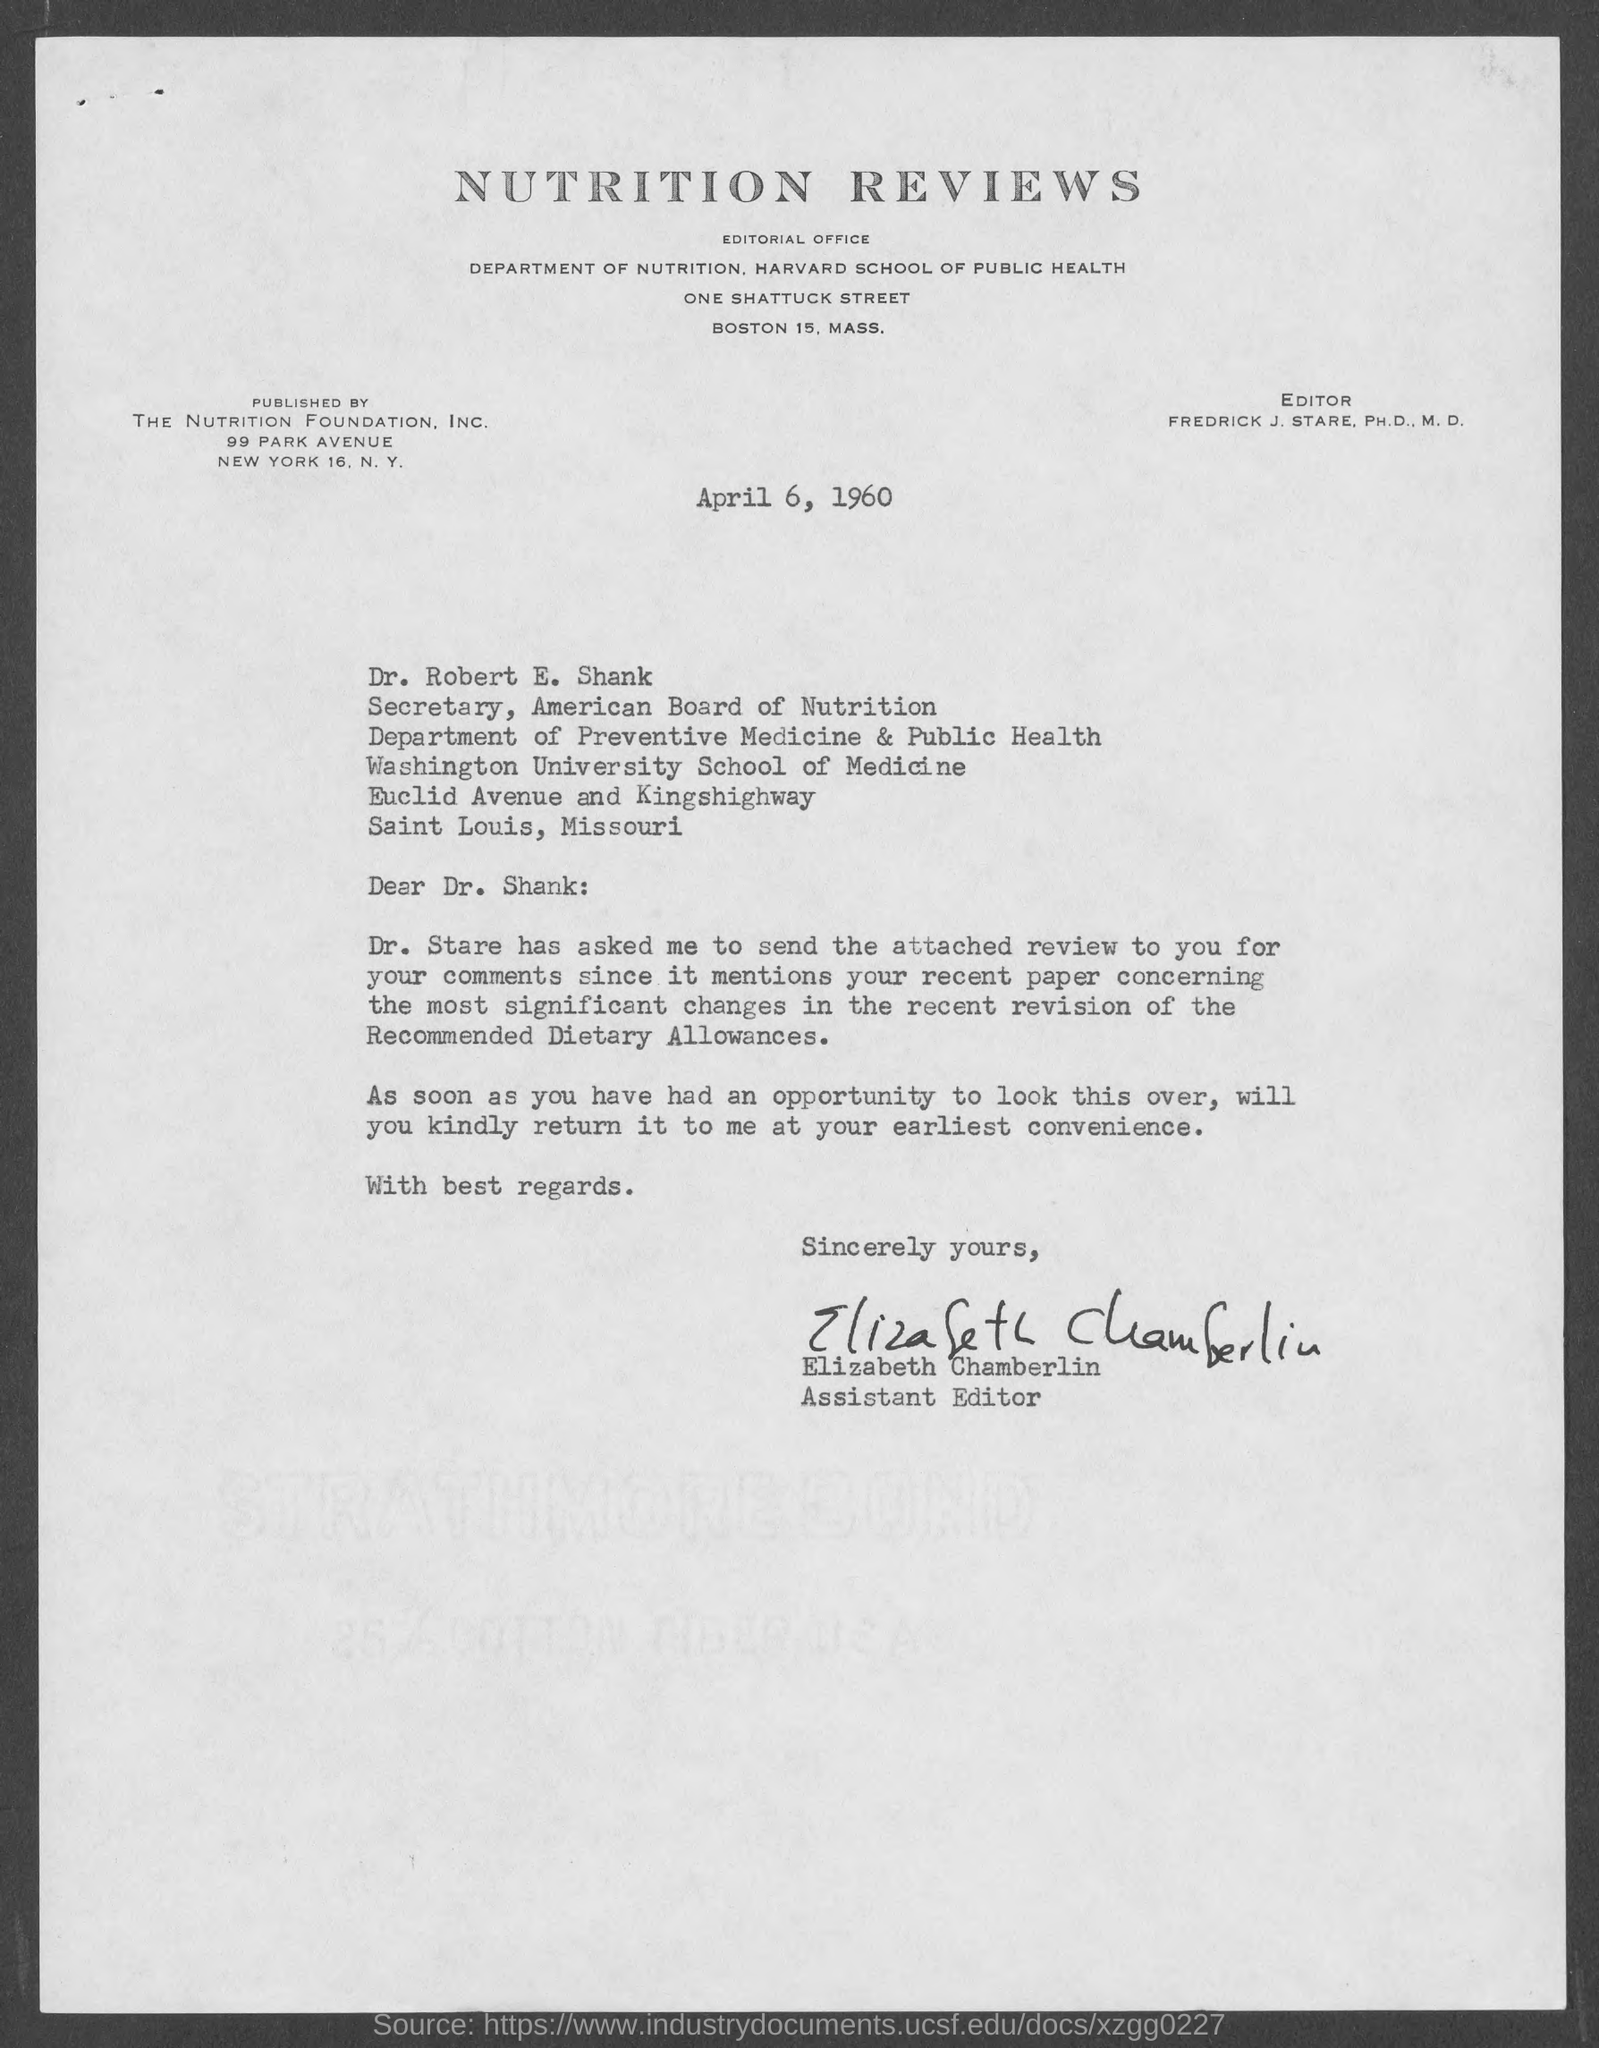Identify some key points in this picture. The Secretary of the American Board of Nutrition is Dr. Robert E. Shank. The Nutrition Foundation, Inc. is the organization that published Nutrition Reviews. It is Elizabeth Chamberlin who serves as the Assistant Editor. 